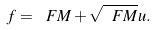Convert formula to latex. <formula><loc_0><loc_0><loc_500><loc_500>f = \ F M + \sqrt { \ F M } u .</formula> 